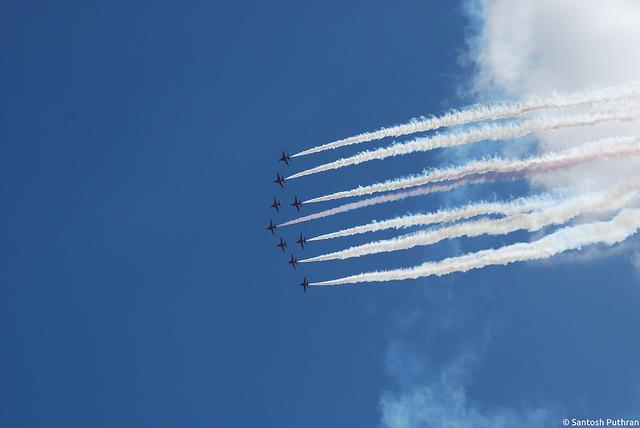What is the white trail behind the plane called? contrails 